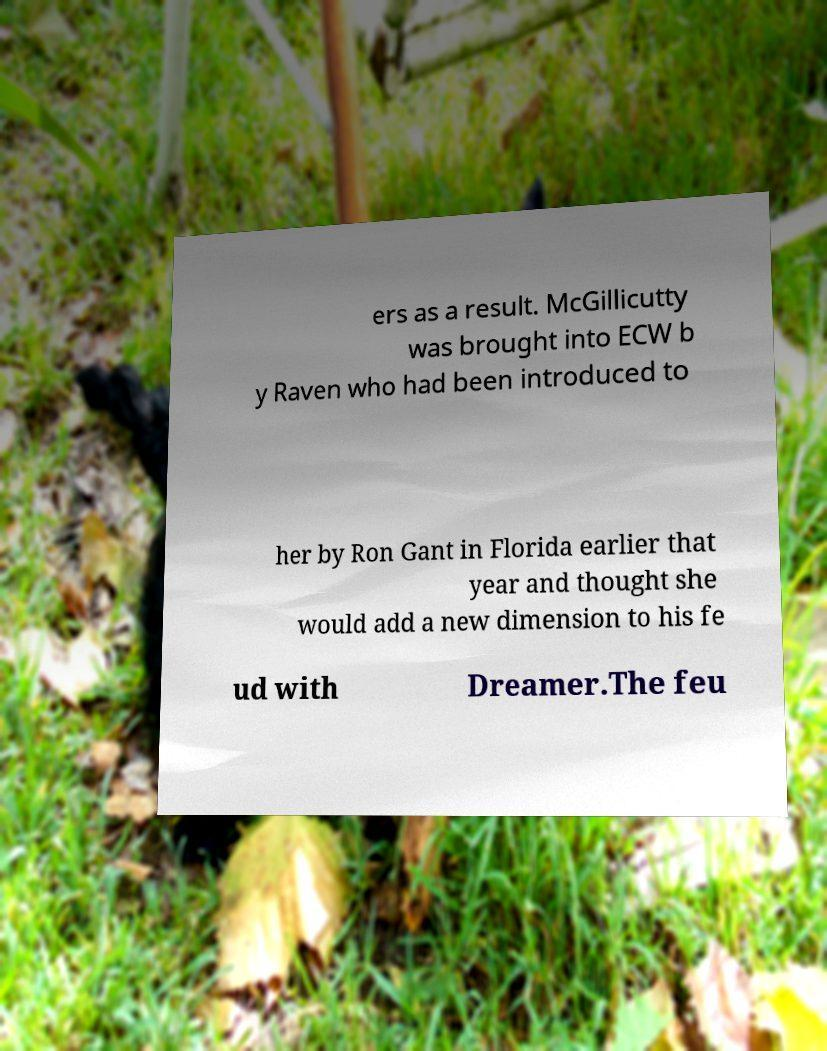Please read and relay the text visible in this image. What does it say? ers as a result. McGillicutty was brought into ECW b y Raven who had been introduced to her by Ron Gant in Florida earlier that year and thought she would add a new dimension to his fe ud with Dreamer.The feu 